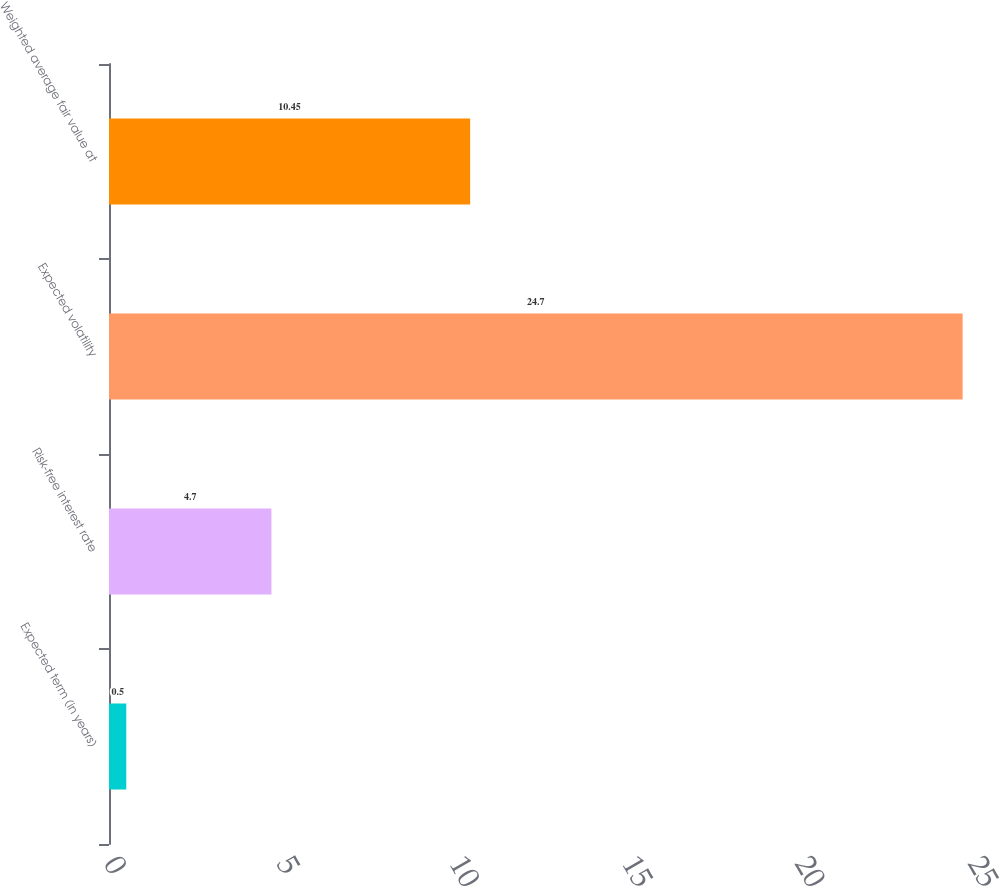<chart> <loc_0><loc_0><loc_500><loc_500><bar_chart><fcel>Expected term (in years)<fcel>Risk-free interest rate<fcel>Expected volatility<fcel>Weighted average fair value at<nl><fcel>0.5<fcel>4.7<fcel>24.7<fcel>10.45<nl></chart> 